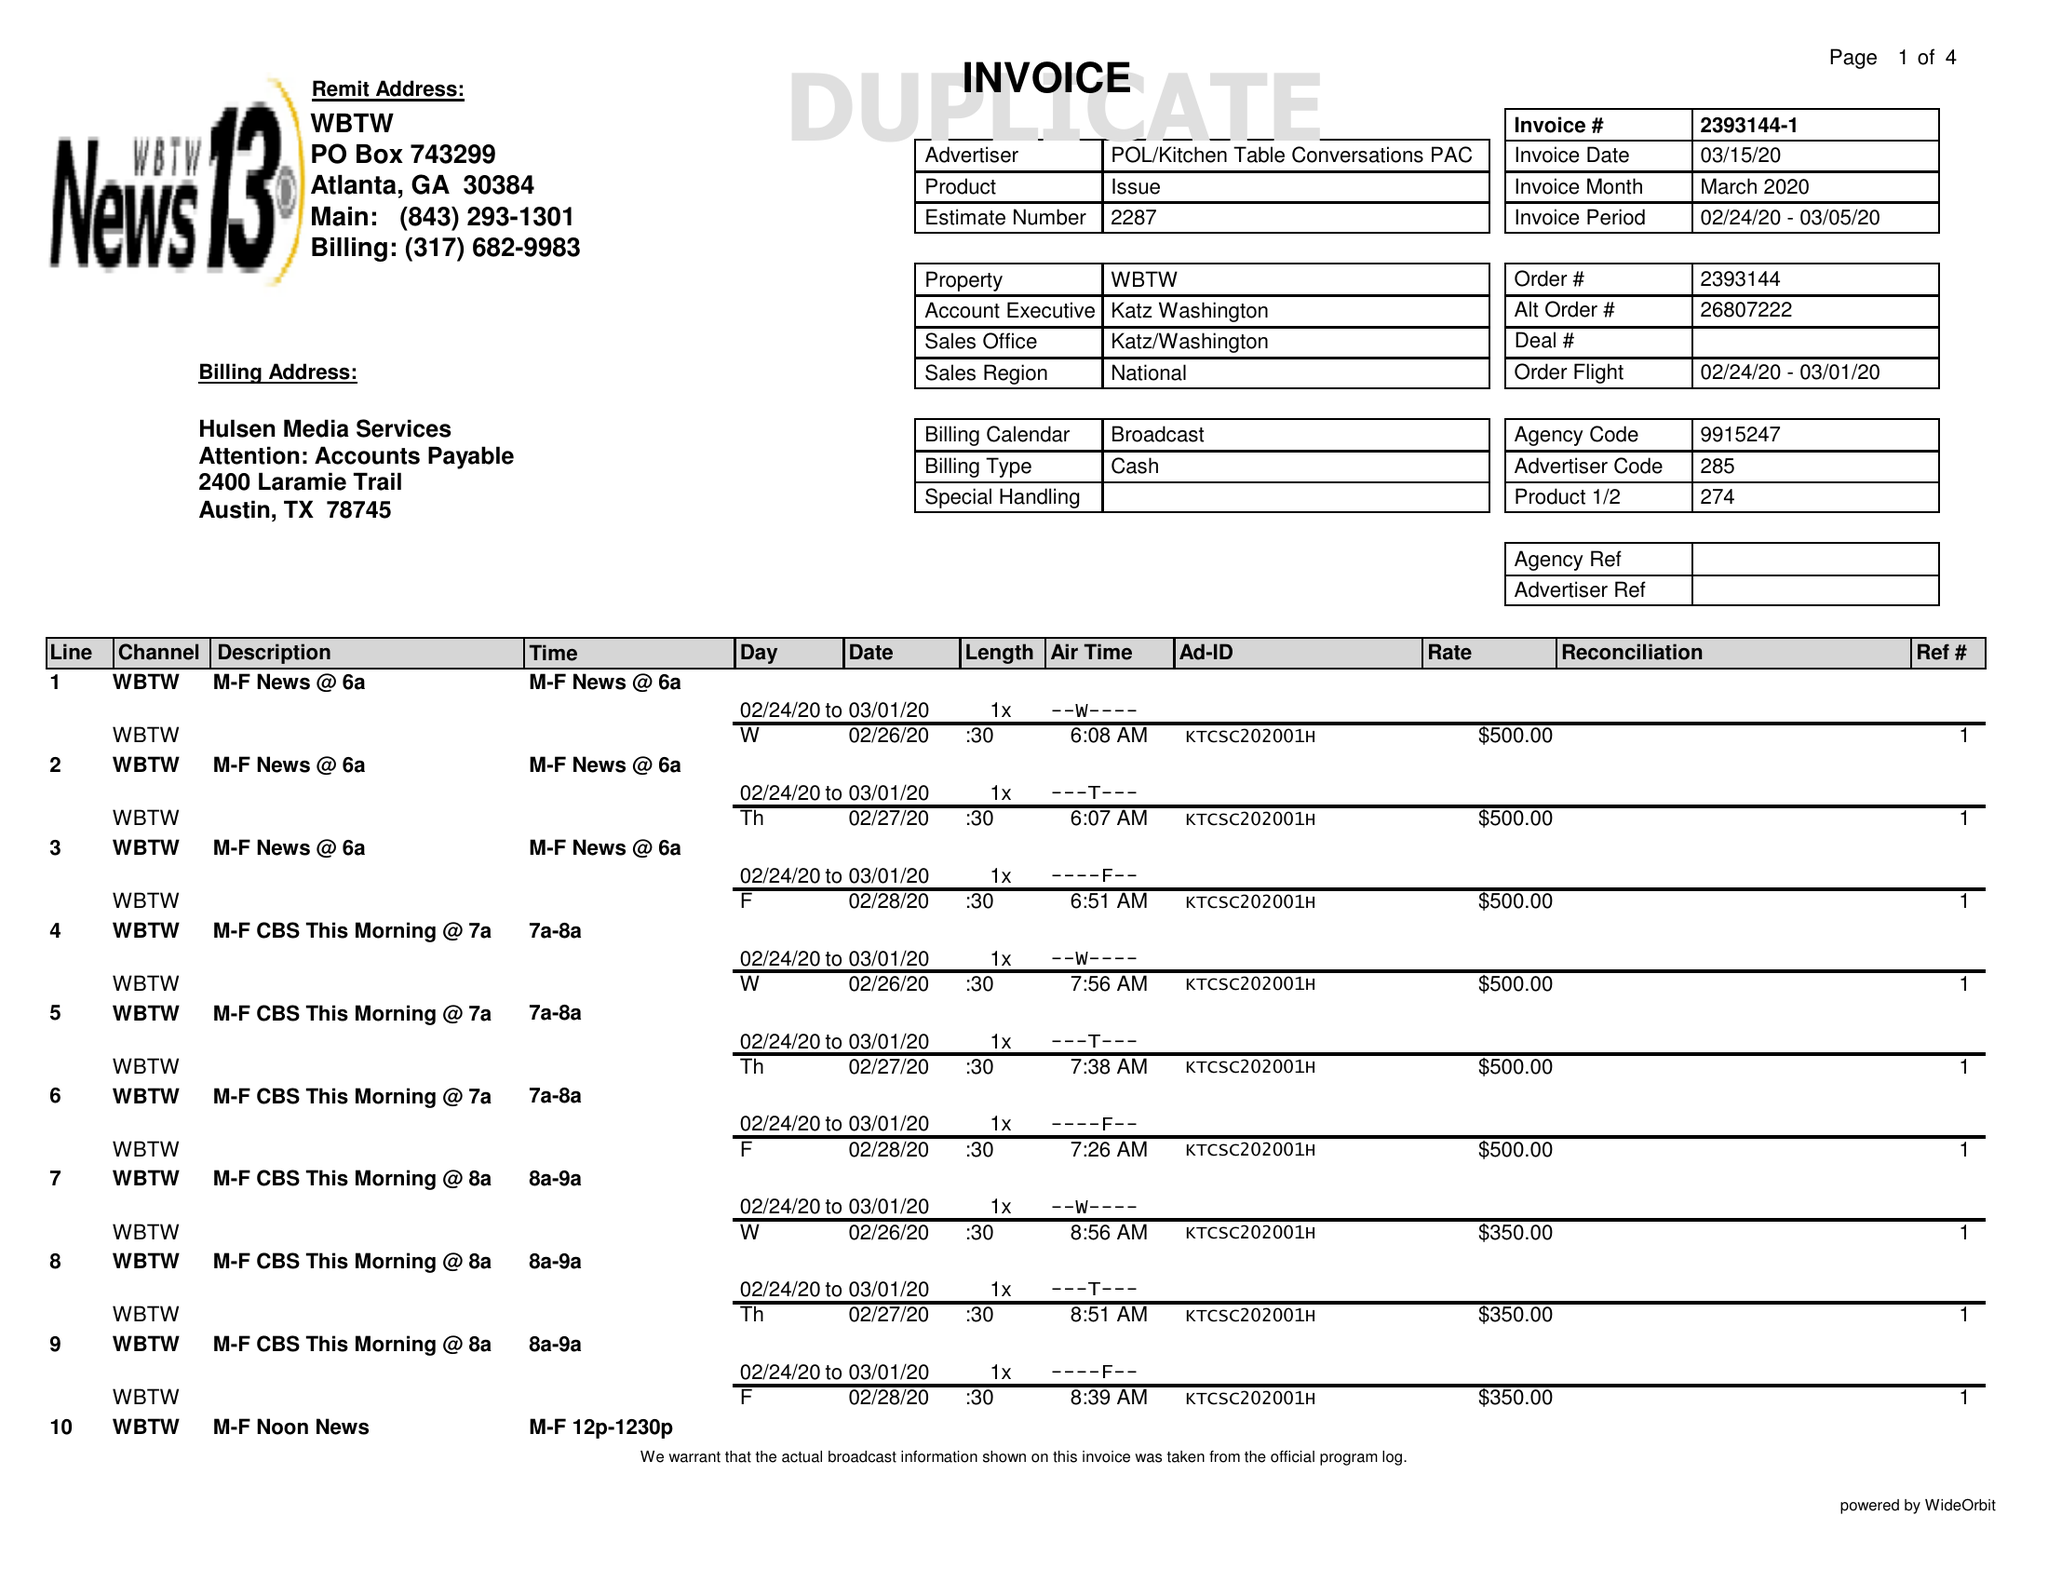What is the value for the gross_amount?
Answer the question using a single word or phrase. 21100.00 